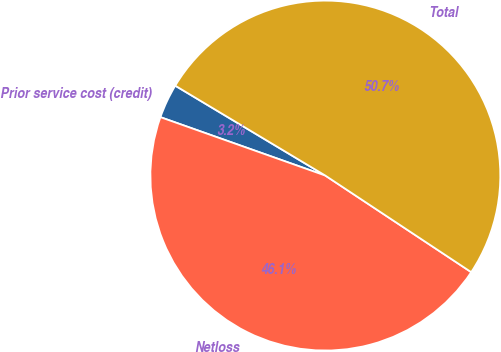Convert chart to OTSL. <chart><loc_0><loc_0><loc_500><loc_500><pie_chart><fcel>Prior service cost (credit)<fcel>Netloss<fcel>Total<nl><fcel>3.17%<fcel>46.11%<fcel>50.72%<nl></chart> 